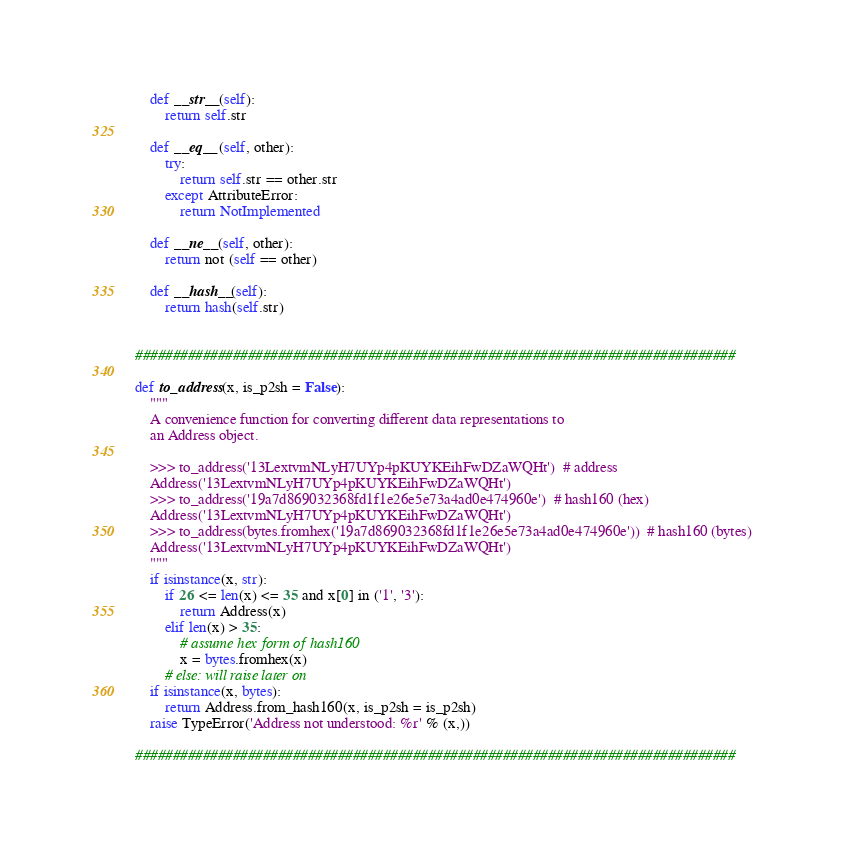Convert code to text. <code><loc_0><loc_0><loc_500><loc_500><_Python_>    def __str__(self):
        return self.str
    
    def __eq__(self, other):
        try:
            return self.str == other.str
        except AttributeError:
            return NotImplemented
    
    def __ne__(self, other):
        return not (self == other)
    
    def __hash__(self):
        return hash(self.str)
    
    
################################################################################

def to_address(x, is_p2sh = False):
    """
    A convenience function for converting different data representations to
    an Address object.
    
    >>> to_address('13LextvmNLyH7UYp4pKUYKEihFwDZaWQHt')  # address
    Address('13LextvmNLyH7UYp4pKUYKEihFwDZaWQHt')
    >>> to_address('19a7d869032368fd1f1e26e5e73a4ad0e474960e')  # hash160 (hex)
    Address('13LextvmNLyH7UYp4pKUYKEihFwDZaWQHt')
    >>> to_address(bytes.fromhex('19a7d869032368fd1f1e26e5e73a4ad0e474960e'))  # hash160 (bytes)
    Address('13LextvmNLyH7UYp4pKUYKEihFwDZaWQHt')
    """
    if isinstance(x, str):
        if 26 <= len(x) <= 35 and x[0] in ('1', '3'):
            return Address(x)
        elif len(x) > 35:
            # assume hex form of hash160
            x = bytes.fromhex(x)
        # else: will raise later on
    if isinstance(x, bytes):
        return Address.from_hash160(x, is_p2sh = is_p2sh)
    raise TypeError('Address not understood: %r' % (x,))

################################################################################

</code> 